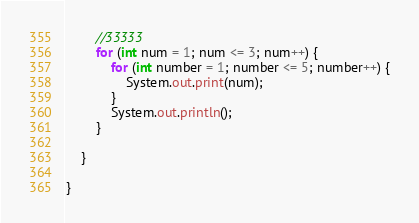Convert code to text. <code><loc_0><loc_0><loc_500><loc_500><_Java_>		//33333
		for (int num = 1; num <= 3; num++) {
			for (int number = 1; number <= 5; number++) {
				System.out.print(num);
			}
			System.out.println();
		}

	}

}
</code> 